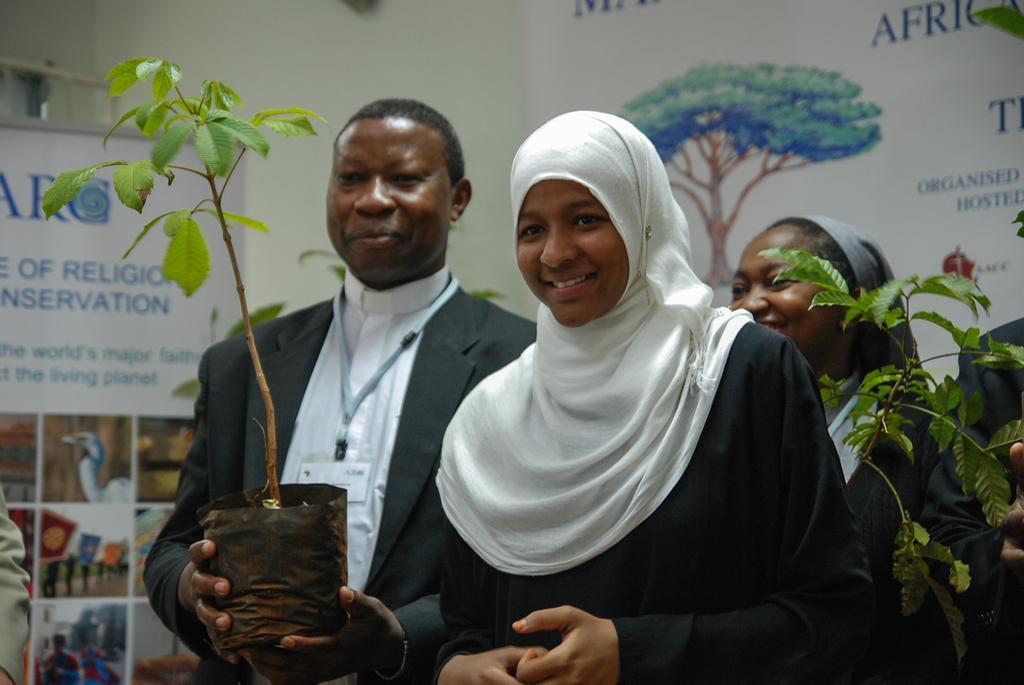Could you give a brief overview of what you see in this image? There are people standing in the foreground area of the image, few of them holding plant pots and there are posters in the background. 